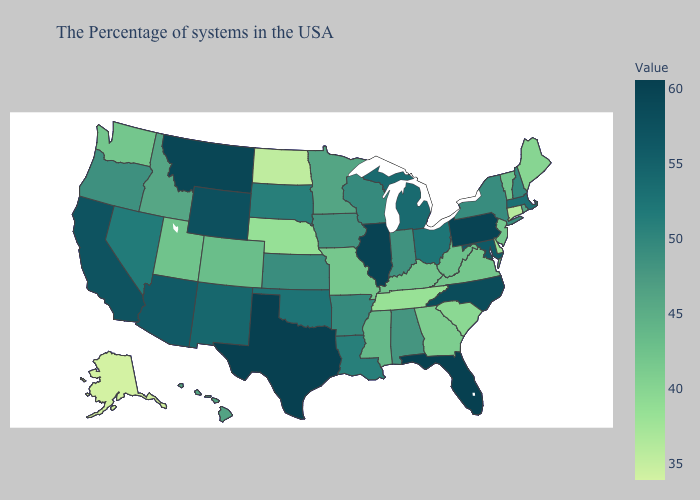Is the legend a continuous bar?
Concise answer only. Yes. Among the states that border Illinois , which have the highest value?
Short answer required. Wisconsin. Does Alaska have the lowest value in the USA?
Be succinct. Yes. Among the states that border New York , which have the lowest value?
Write a very short answer. Connecticut. 